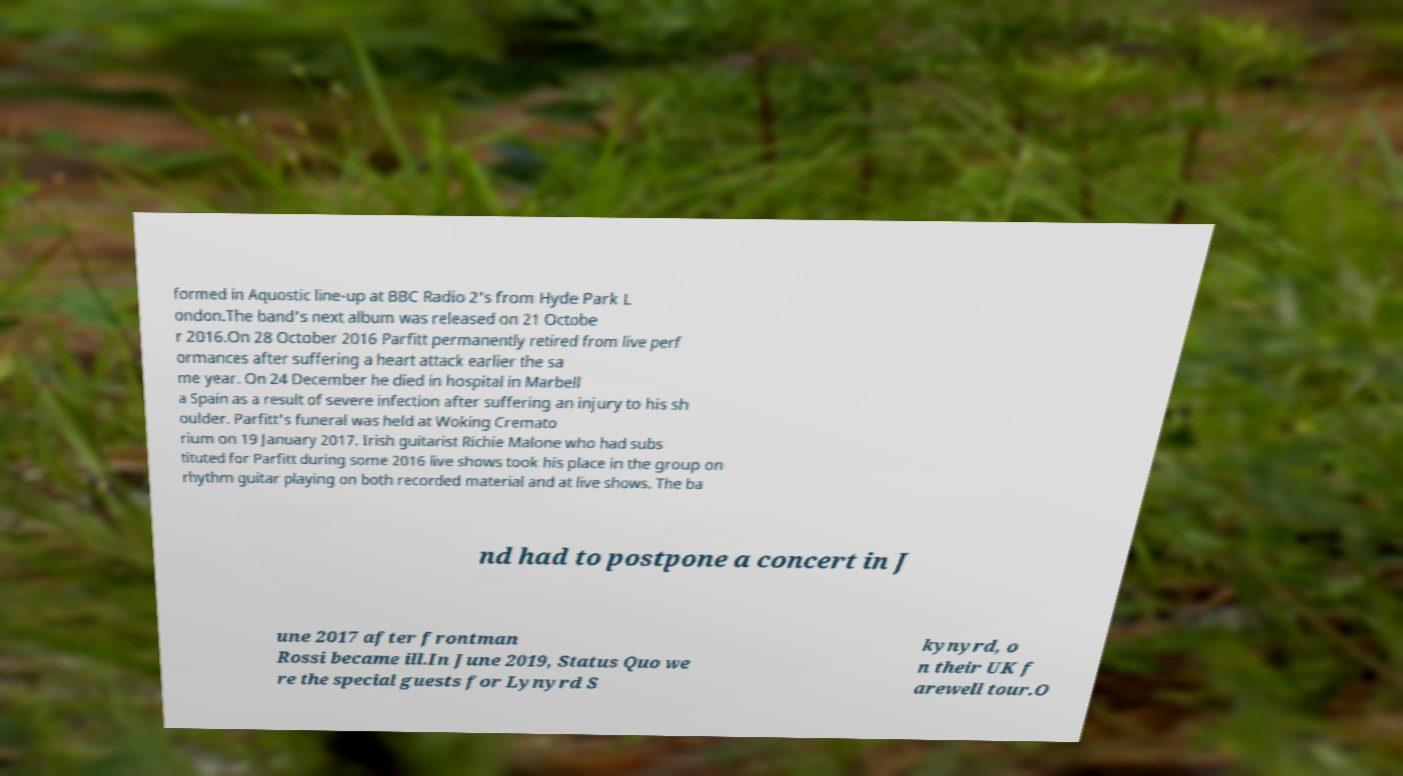What messages or text are displayed in this image? I need them in a readable, typed format. formed in Aquostic line-up at BBC Radio 2's from Hyde Park L ondon.The band's next album was released on 21 Octobe r 2016.On 28 October 2016 Parfitt permanently retired from live perf ormances after suffering a heart attack earlier the sa me year. On 24 December he died in hospital in Marbell a Spain as a result of severe infection after suffering an injury to his sh oulder. Parfitt's funeral was held at Woking Cremato rium on 19 January 2017. Irish guitarist Richie Malone who had subs tituted for Parfitt during some 2016 live shows took his place in the group on rhythm guitar playing on both recorded material and at live shows. The ba nd had to postpone a concert in J une 2017 after frontman Rossi became ill.In June 2019, Status Quo we re the special guests for Lynyrd S kynyrd, o n their UK f arewell tour.O 